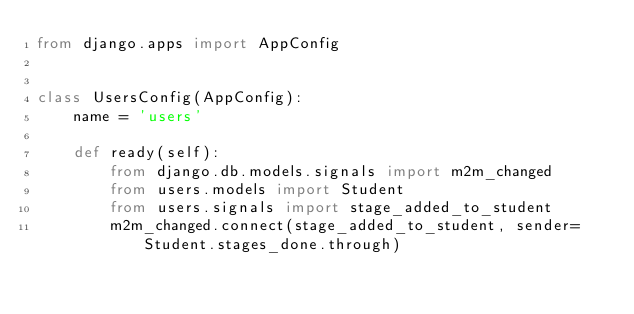<code> <loc_0><loc_0><loc_500><loc_500><_Python_>from django.apps import AppConfig


class UsersConfig(AppConfig):
    name = 'users'

    def ready(self):
        from django.db.models.signals import m2m_changed
        from users.models import Student
        from users.signals import stage_added_to_student
        m2m_changed.connect(stage_added_to_student, sender=Student.stages_done.through)
</code> 